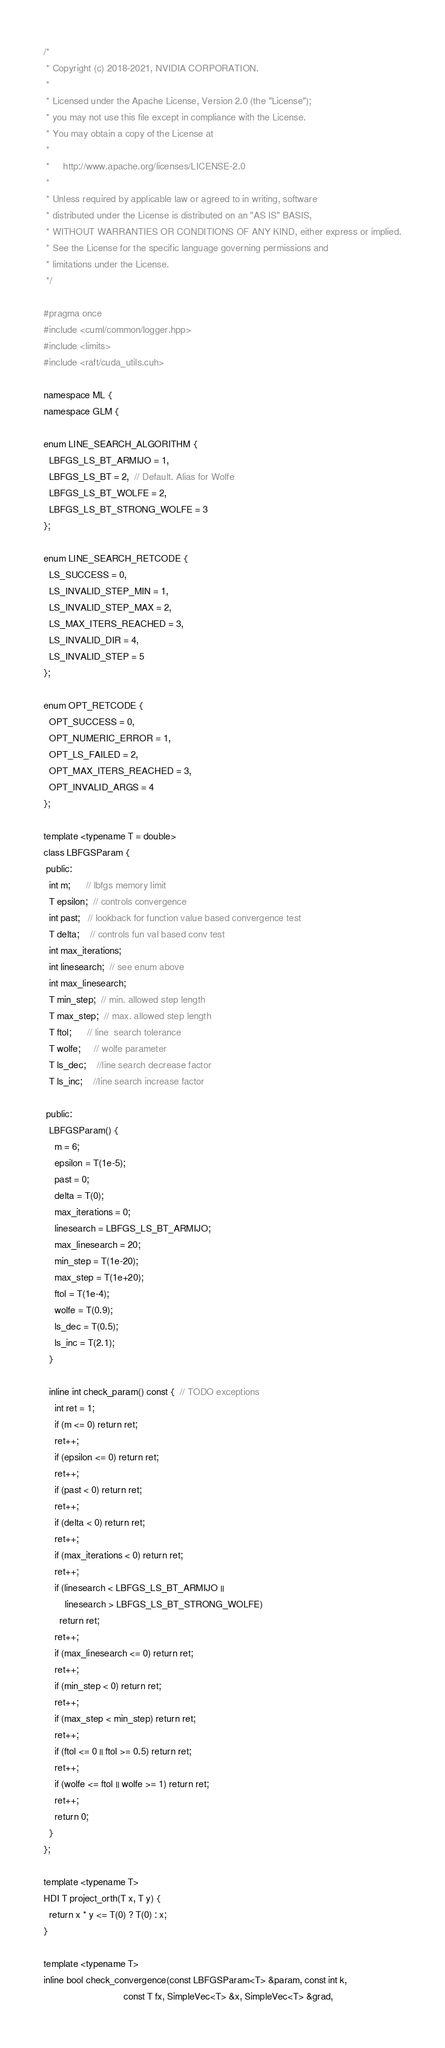Convert code to text. <code><loc_0><loc_0><loc_500><loc_500><_Cuda_>/*
 * Copyright (c) 2018-2021, NVIDIA CORPORATION.
 *
 * Licensed under the Apache License, Version 2.0 (the "License");
 * you may not use this file except in compliance with the License.
 * You may obtain a copy of the License at
 *
 *     http://www.apache.org/licenses/LICENSE-2.0
 *
 * Unless required by applicable law or agreed to in writing, software
 * distributed under the License is distributed on an "AS IS" BASIS,
 * WITHOUT WARRANTIES OR CONDITIONS OF ANY KIND, either express or implied.
 * See the License for the specific language governing permissions and
 * limitations under the License.
 */

#pragma once
#include <cuml/common/logger.hpp>
#include <limits>
#include <raft/cuda_utils.cuh>

namespace ML {
namespace GLM {

enum LINE_SEARCH_ALGORITHM {
  LBFGS_LS_BT_ARMIJO = 1,
  LBFGS_LS_BT = 2,  // Default. Alias for Wolfe
  LBFGS_LS_BT_WOLFE = 2,
  LBFGS_LS_BT_STRONG_WOLFE = 3
};

enum LINE_SEARCH_RETCODE {
  LS_SUCCESS = 0,
  LS_INVALID_STEP_MIN = 1,
  LS_INVALID_STEP_MAX = 2,
  LS_MAX_ITERS_REACHED = 3,
  LS_INVALID_DIR = 4,
  LS_INVALID_STEP = 5
};

enum OPT_RETCODE {
  OPT_SUCCESS = 0,
  OPT_NUMERIC_ERROR = 1,
  OPT_LS_FAILED = 2,
  OPT_MAX_ITERS_REACHED = 3,
  OPT_INVALID_ARGS = 4
};

template <typename T = double>
class LBFGSParam {
 public:
  int m;      // lbfgs memory limit
  T epsilon;  // controls convergence
  int past;   // lookback for function value based convergence test
  T delta;    // controls fun val based conv test
  int max_iterations;
  int linesearch;  // see enum above
  int max_linesearch;
  T min_step;  // min. allowed step length
  T max_step;  // max. allowed step length
  T ftol;      // line  search tolerance
  T wolfe;     // wolfe parameter
  T ls_dec;    //line search decrease factor
  T ls_inc;    //line search increase factor

 public:
  LBFGSParam() {
    m = 6;
    epsilon = T(1e-5);
    past = 0;
    delta = T(0);
    max_iterations = 0;
    linesearch = LBFGS_LS_BT_ARMIJO;
    max_linesearch = 20;
    min_step = T(1e-20);
    max_step = T(1e+20);
    ftol = T(1e-4);
    wolfe = T(0.9);
    ls_dec = T(0.5);
    ls_inc = T(2.1);
  }

  inline int check_param() const {  // TODO exceptions
    int ret = 1;
    if (m <= 0) return ret;
    ret++;
    if (epsilon <= 0) return ret;
    ret++;
    if (past < 0) return ret;
    ret++;
    if (delta < 0) return ret;
    ret++;
    if (max_iterations < 0) return ret;
    ret++;
    if (linesearch < LBFGS_LS_BT_ARMIJO ||
        linesearch > LBFGS_LS_BT_STRONG_WOLFE)
      return ret;
    ret++;
    if (max_linesearch <= 0) return ret;
    ret++;
    if (min_step < 0) return ret;
    ret++;
    if (max_step < min_step) return ret;
    ret++;
    if (ftol <= 0 || ftol >= 0.5) return ret;
    ret++;
    if (wolfe <= ftol || wolfe >= 1) return ret;
    ret++;
    return 0;
  }
};

template <typename T>
HDI T project_orth(T x, T y) {
  return x * y <= T(0) ? T(0) : x;
}

template <typename T>
inline bool check_convergence(const LBFGSParam<T> &param, const int k,
                              const T fx, SimpleVec<T> &x, SimpleVec<T> &grad,</code> 